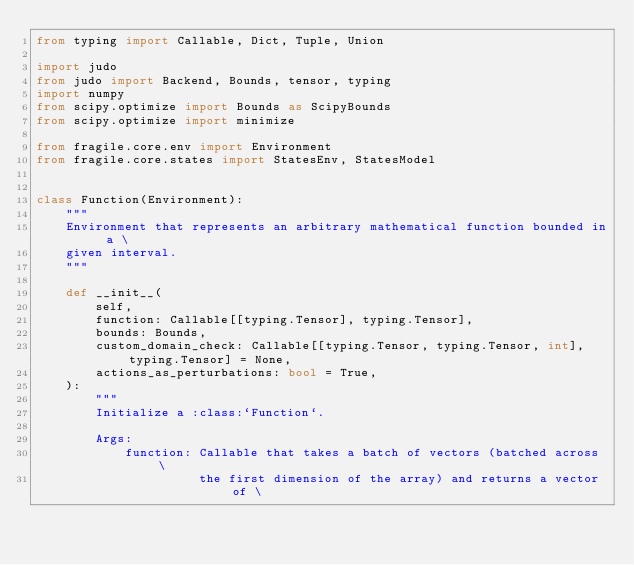<code> <loc_0><loc_0><loc_500><loc_500><_Python_>from typing import Callable, Dict, Tuple, Union

import judo
from judo import Backend, Bounds, tensor, typing
import numpy
from scipy.optimize import Bounds as ScipyBounds
from scipy.optimize import minimize

from fragile.core.env import Environment
from fragile.core.states import StatesEnv, StatesModel


class Function(Environment):
    """
    Environment that represents an arbitrary mathematical function bounded in a \
    given interval.
    """

    def __init__(
        self,
        function: Callable[[typing.Tensor], typing.Tensor],
        bounds: Bounds,
        custom_domain_check: Callable[[typing.Tensor, typing.Tensor, int], typing.Tensor] = None,
        actions_as_perturbations: bool = True,
    ):
        """
        Initialize a :class:`Function`.

        Args:
            function: Callable that takes a batch of vectors (batched across \
                      the first dimension of the array) and returns a vector of \</code> 